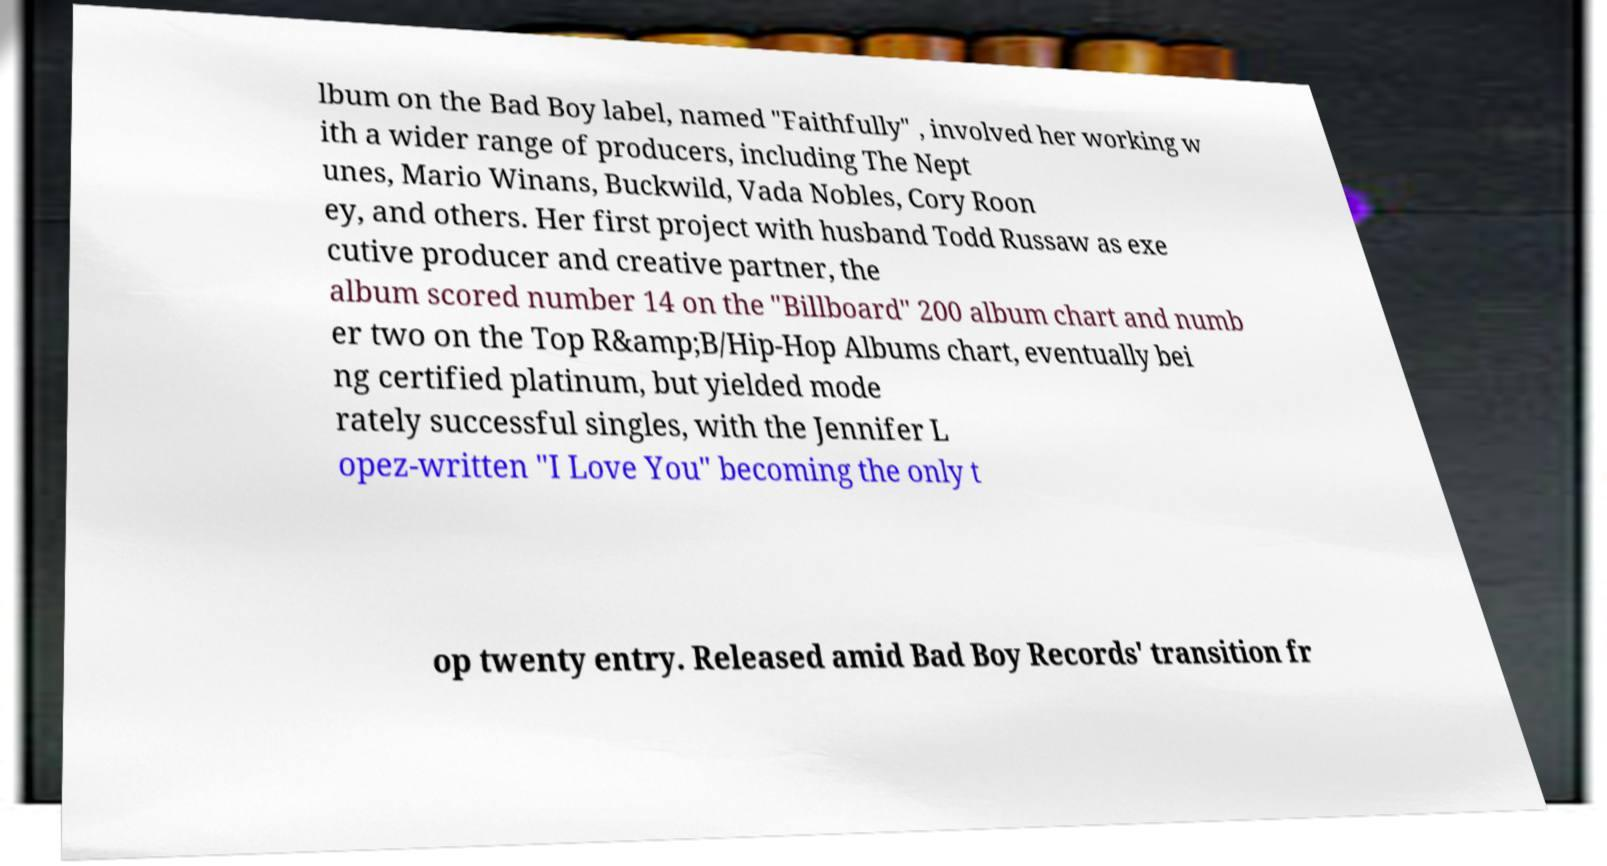For documentation purposes, I need the text within this image transcribed. Could you provide that? lbum on the Bad Boy label, named "Faithfully" , involved her working w ith a wider range of producers, including The Nept unes, Mario Winans, Buckwild, Vada Nobles, Cory Roon ey, and others. Her first project with husband Todd Russaw as exe cutive producer and creative partner, the album scored number 14 on the "Billboard" 200 album chart and numb er two on the Top R&amp;B/Hip-Hop Albums chart, eventually bei ng certified platinum, but yielded mode rately successful singles, with the Jennifer L opez-written "I Love You" becoming the only t op twenty entry. Released amid Bad Boy Records' transition fr 